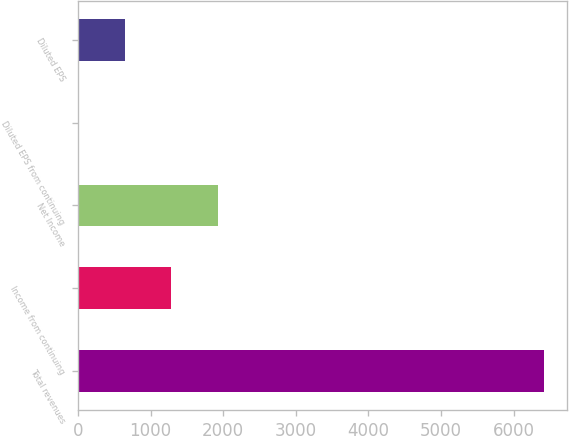Convert chart. <chart><loc_0><loc_0><loc_500><loc_500><bar_chart><fcel>Total revenues<fcel>Income from continuing<fcel>Net Income<fcel>Diluted EPS from continuing<fcel>Diluted EPS<nl><fcel>6418<fcel>1285.27<fcel>1926.86<fcel>2.09<fcel>643.68<nl></chart> 